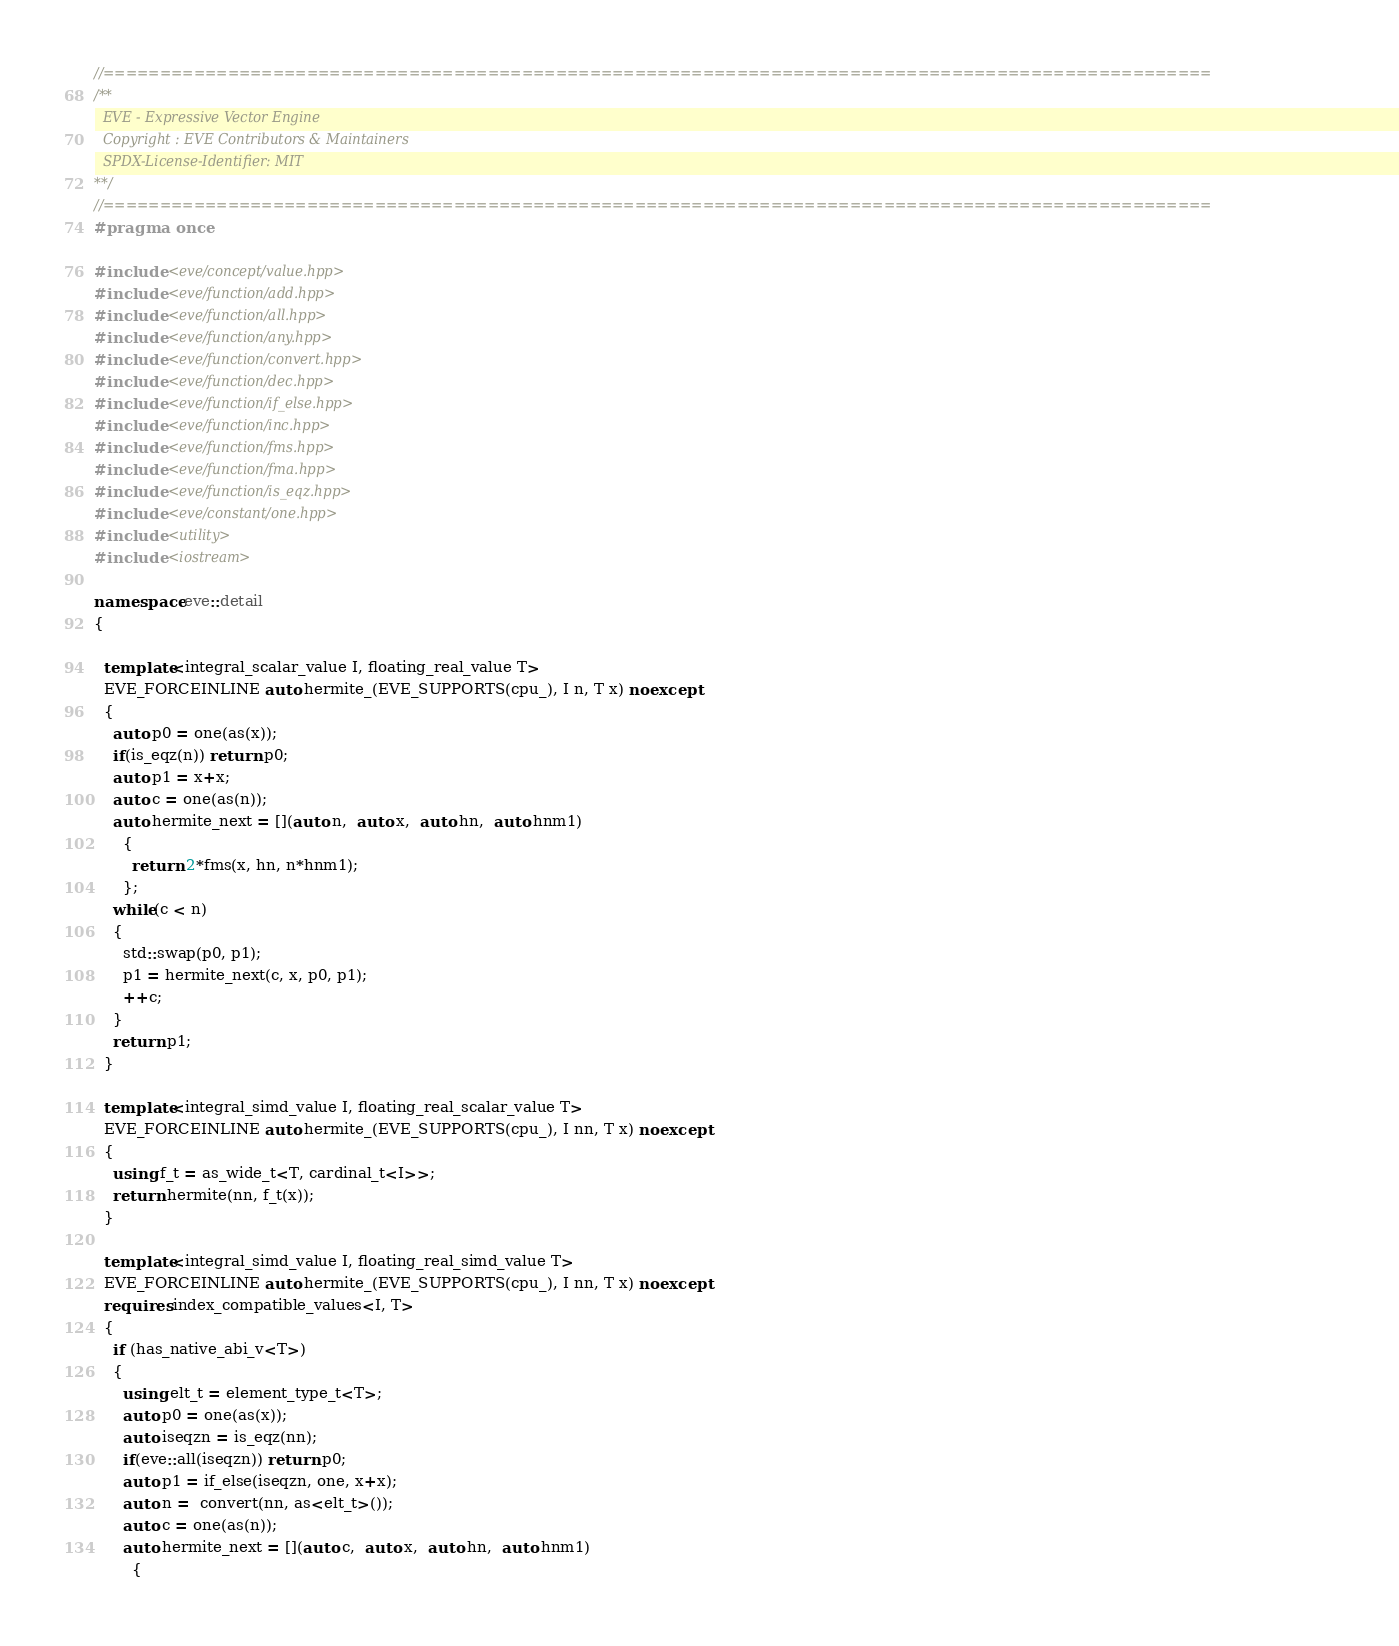<code> <loc_0><loc_0><loc_500><loc_500><_C++_>//==================================================================================================
/**
  EVE - Expressive Vector Engine
  Copyright : EVE Contributors & Maintainers
  SPDX-License-Identifier: MIT
**/
//==================================================================================================
#pragma once

#include <eve/concept/value.hpp>
#include <eve/function/add.hpp>
#include <eve/function/all.hpp>
#include <eve/function/any.hpp>
#include <eve/function/convert.hpp>
#include <eve/function/dec.hpp>
#include <eve/function/if_else.hpp>
#include <eve/function/inc.hpp>
#include <eve/function/fms.hpp>
#include <eve/function/fma.hpp>
#include <eve/function/is_eqz.hpp>
#include <eve/constant/one.hpp>
#include <utility>
#include <iostream>

namespace eve::detail
{

  template<integral_scalar_value I, floating_real_value T>
  EVE_FORCEINLINE auto hermite_(EVE_SUPPORTS(cpu_), I n, T x) noexcept
  {
    auto p0 = one(as(x));
    if(is_eqz(n)) return p0;
    auto p1 = x+x;
    auto c = one(as(n));
    auto hermite_next = [](auto n,  auto x,  auto hn,  auto hnm1)
      {
        return 2*fms(x, hn, n*hnm1);
      };
    while(c < n)
    {
      std::swap(p0, p1);
      p1 = hermite_next(c, x, p0, p1);
      ++c;
    }
    return p1;
  }

  template<integral_simd_value I, floating_real_scalar_value T>
  EVE_FORCEINLINE auto hermite_(EVE_SUPPORTS(cpu_), I nn, T x) noexcept
  {
    using f_t = as_wide_t<T, cardinal_t<I>>;
    return hermite(nn, f_t(x));
  }

  template<integral_simd_value I, floating_real_simd_value T>
  EVE_FORCEINLINE auto hermite_(EVE_SUPPORTS(cpu_), I nn, T x) noexcept
  requires index_compatible_values<I, T>
  {
    if (has_native_abi_v<T>)
    {
      using elt_t = element_type_t<T>;
      auto p0 = one(as(x));
      auto iseqzn = is_eqz(nn);
      if(eve::all(iseqzn)) return p0;
      auto p1 = if_else(iseqzn, one, x+x);
      auto n =  convert(nn, as<elt_t>());
      auto c = one(as(n));
      auto hermite_next = [](auto c,  auto x,  auto hn,  auto hnm1)
        {</code> 